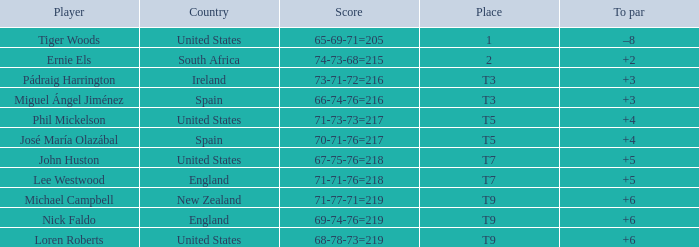What is Player, when Country is "England", and when Place is "T7"? Lee Westwood. 